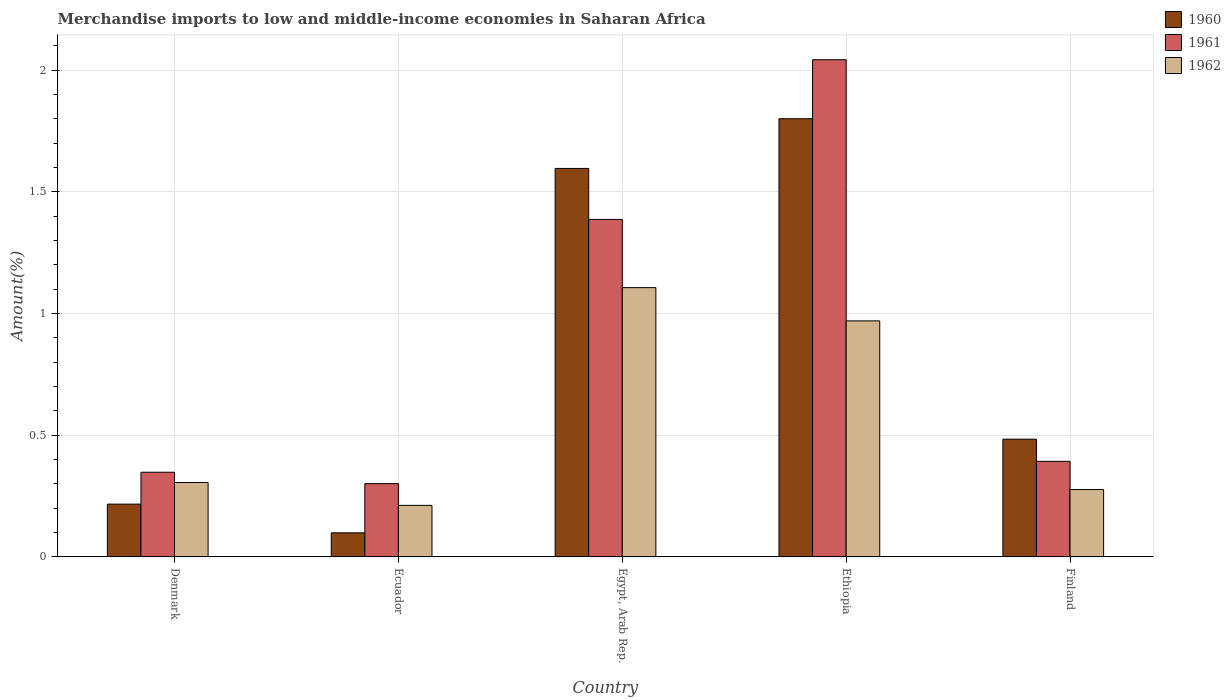How many groups of bars are there?
Give a very brief answer. 5. Are the number of bars per tick equal to the number of legend labels?
Make the answer very short. Yes. Are the number of bars on each tick of the X-axis equal?
Ensure brevity in your answer.  Yes. What is the label of the 4th group of bars from the left?
Keep it short and to the point. Ethiopia. In how many cases, is the number of bars for a given country not equal to the number of legend labels?
Offer a terse response. 0. What is the percentage of amount earned from merchandise imports in 1960 in Ecuador?
Make the answer very short. 0.1. Across all countries, what is the maximum percentage of amount earned from merchandise imports in 1960?
Give a very brief answer. 1.8. Across all countries, what is the minimum percentage of amount earned from merchandise imports in 1961?
Ensure brevity in your answer.  0.3. In which country was the percentage of amount earned from merchandise imports in 1962 maximum?
Make the answer very short. Egypt, Arab Rep. In which country was the percentage of amount earned from merchandise imports in 1960 minimum?
Make the answer very short. Ecuador. What is the total percentage of amount earned from merchandise imports in 1962 in the graph?
Provide a short and direct response. 2.87. What is the difference between the percentage of amount earned from merchandise imports in 1960 in Denmark and that in Egypt, Arab Rep.?
Make the answer very short. -1.38. What is the difference between the percentage of amount earned from merchandise imports in 1962 in Ecuador and the percentage of amount earned from merchandise imports in 1961 in Finland?
Keep it short and to the point. -0.18. What is the average percentage of amount earned from merchandise imports in 1960 per country?
Ensure brevity in your answer.  0.84. What is the difference between the percentage of amount earned from merchandise imports of/in 1960 and percentage of amount earned from merchandise imports of/in 1961 in Egypt, Arab Rep.?
Give a very brief answer. 0.21. What is the ratio of the percentage of amount earned from merchandise imports in 1960 in Ethiopia to that in Finland?
Provide a succinct answer. 3.72. Is the percentage of amount earned from merchandise imports in 1961 in Denmark less than that in Ethiopia?
Your response must be concise. Yes. Is the difference between the percentage of amount earned from merchandise imports in 1960 in Ethiopia and Finland greater than the difference between the percentage of amount earned from merchandise imports in 1961 in Ethiopia and Finland?
Your response must be concise. No. What is the difference between the highest and the second highest percentage of amount earned from merchandise imports in 1961?
Your response must be concise. -0.99. What is the difference between the highest and the lowest percentage of amount earned from merchandise imports in 1960?
Ensure brevity in your answer.  1.7. What does the 1st bar from the left in Ethiopia represents?
Provide a short and direct response. 1960. How many bars are there?
Keep it short and to the point. 15. What is the difference between two consecutive major ticks on the Y-axis?
Your response must be concise. 0.5. Are the values on the major ticks of Y-axis written in scientific E-notation?
Ensure brevity in your answer.  No. Does the graph contain grids?
Make the answer very short. Yes. Where does the legend appear in the graph?
Offer a terse response. Top right. How many legend labels are there?
Ensure brevity in your answer.  3. How are the legend labels stacked?
Your answer should be very brief. Vertical. What is the title of the graph?
Your answer should be very brief. Merchandise imports to low and middle-income economies in Saharan Africa. Does "1970" appear as one of the legend labels in the graph?
Provide a succinct answer. No. What is the label or title of the X-axis?
Your answer should be very brief. Country. What is the label or title of the Y-axis?
Provide a succinct answer. Amount(%). What is the Amount(%) in 1960 in Denmark?
Provide a succinct answer. 0.22. What is the Amount(%) of 1961 in Denmark?
Provide a short and direct response. 0.35. What is the Amount(%) of 1962 in Denmark?
Your answer should be very brief. 0.31. What is the Amount(%) in 1960 in Ecuador?
Offer a very short reply. 0.1. What is the Amount(%) in 1961 in Ecuador?
Keep it short and to the point. 0.3. What is the Amount(%) in 1962 in Ecuador?
Give a very brief answer. 0.21. What is the Amount(%) of 1960 in Egypt, Arab Rep.?
Offer a very short reply. 1.6. What is the Amount(%) of 1961 in Egypt, Arab Rep.?
Your answer should be compact. 1.39. What is the Amount(%) of 1962 in Egypt, Arab Rep.?
Offer a terse response. 1.11. What is the Amount(%) in 1960 in Ethiopia?
Your answer should be compact. 1.8. What is the Amount(%) in 1961 in Ethiopia?
Provide a succinct answer. 2.04. What is the Amount(%) in 1962 in Ethiopia?
Provide a short and direct response. 0.97. What is the Amount(%) in 1960 in Finland?
Keep it short and to the point. 0.48. What is the Amount(%) of 1961 in Finland?
Make the answer very short. 0.39. What is the Amount(%) in 1962 in Finland?
Offer a terse response. 0.28. Across all countries, what is the maximum Amount(%) in 1960?
Provide a short and direct response. 1.8. Across all countries, what is the maximum Amount(%) in 1961?
Offer a very short reply. 2.04. Across all countries, what is the maximum Amount(%) in 1962?
Ensure brevity in your answer.  1.11. Across all countries, what is the minimum Amount(%) of 1960?
Your answer should be compact. 0.1. Across all countries, what is the minimum Amount(%) in 1961?
Give a very brief answer. 0.3. Across all countries, what is the minimum Amount(%) in 1962?
Ensure brevity in your answer.  0.21. What is the total Amount(%) in 1960 in the graph?
Your answer should be compact. 4.2. What is the total Amount(%) of 1961 in the graph?
Make the answer very short. 4.47. What is the total Amount(%) of 1962 in the graph?
Your response must be concise. 2.87. What is the difference between the Amount(%) of 1960 in Denmark and that in Ecuador?
Give a very brief answer. 0.12. What is the difference between the Amount(%) of 1961 in Denmark and that in Ecuador?
Provide a succinct answer. 0.05. What is the difference between the Amount(%) in 1962 in Denmark and that in Ecuador?
Provide a short and direct response. 0.09. What is the difference between the Amount(%) in 1960 in Denmark and that in Egypt, Arab Rep.?
Provide a succinct answer. -1.38. What is the difference between the Amount(%) of 1961 in Denmark and that in Egypt, Arab Rep.?
Give a very brief answer. -1.04. What is the difference between the Amount(%) of 1962 in Denmark and that in Egypt, Arab Rep.?
Make the answer very short. -0.8. What is the difference between the Amount(%) in 1960 in Denmark and that in Ethiopia?
Your response must be concise. -1.58. What is the difference between the Amount(%) of 1961 in Denmark and that in Ethiopia?
Your answer should be compact. -1.7. What is the difference between the Amount(%) of 1962 in Denmark and that in Ethiopia?
Your response must be concise. -0.66. What is the difference between the Amount(%) in 1960 in Denmark and that in Finland?
Make the answer very short. -0.27. What is the difference between the Amount(%) in 1961 in Denmark and that in Finland?
Ensure brevity in your answer.  -0.04. What is the difference between the Amount(%) of 1962 in Denmark and that in Finland?
Provide a succinct answer. 0.03. What is the difference between the Amount(%) in 1960 in Ecuador and that in Egypt, Arab Rep.?
Keep it short and to the point. -1.5. What is the difference between the Amount(%) of 1961 in Ecuador and that in Egypt, Arab Rep.?
Your answer should be compact. -1.09. What is the difference between the Amount(%) in 1962 in Ecuador and that in Egypt, Arab Rep.?
Keep it short and to the point. -0.89. What is the difference between the Amount(%) of 1960 in Ecuador and that in Ethiopia?
Provide a short and direct response. -1.7. What is the difference between the Amount(%) in 1961 in Ecuador and that in Ethiopia?
Offer a terse response. -1.74. What is the difference between the Amount(%) in 1962 in Ecuador and that in Ethiopia?
Provide a succinct answer. -0.76. What is the difference between the Amount(%) of 1960 in Ecuador and that in Finland?
Offer a terse response. -0.38. What is the difference between the Amount(%) in 1961 in Ecuador and that in Finland?
Provide a succinct answer. -0.09. What is the difference between the Amount(%) of 1962 in Ecuador and that in Finland?
Provide a succinct answer. -0.07. What is the difference between the Amount(%) of 1960 in Egypt, Arab Rep. and that in Ethiopia?
Keep it short and to the point. -0.2. What is the difference between the Amount(%) in 1961 in Egypt, Arab Rep. and that in Ethiopia?
Your answer should be very brief. -0.66. What is the difference between the Amount(%) of 1962 in Egypt, Arab Rep. and that in Ethiopia?
Give a very brief answer. 0.14. What is the difference between the Amount(%) in 1960 in Egypt, Arab Rep. and that in Finland?
Your answer should be compact. 1.11. What is the difference between the Amount(%) in 1961 in Egypt, Arab Rep. and that in Finland?
Make the answer very short. 0.99. What is the difference between the Amount(%) in 1962 in Egypt, Arab Rep. and that in Finland?
Ensure brevity in your answer.  0.83. What is the difference between the Amount(%) in 1960 in Ethiopia and that in Finland?
Offer a terse response. 1.32. What is the difference between the Amount(%) of 1961 in Ethiopia and that in Finland?
Provide a short and direct response. 1.65. What is the difference between the Amount(%) in 1962 in Ethiopia and that in Finland?
Make the answer very short. 0.69. What is the difference between the Amount(%) in 1960 in Denmark and the Amount(%) in 1961 in Ecuador?
Make the answer very short. -0.08. What is the difference between the Amount(%) in 1960 in Denmark and the Amount(%) in 1962 in Ecuador?
Offer a terse response. 0.01. What is the difference between the Amount(%) in 1961 in Denmark and the Amount(%) in 1962 in Ecuador?
Provide a succinct answer. 0.14. What is the difference between the Amount(%) of 1960 in Denmark and the Amount(%) of 1961 in Egypt, Arab Rep.?
Give a very brief answer. -1.17. What is the difference between the Amount(%) of 1960 in Denmark and the Amount(%) of 1962 in Egypt, Arab Rep.?
Offer a terse response. -0.89. What is the difference between the Amount(%) in 1961 in Denmark and the Amount(%) in 1962 in Egypt, Arab Rep.?
Provide a succinct answer. -0.76. What is the difference between the Amount(%) of 1960 in Denmark and the Amount(%) of 1961 in Ethiopia?
Offer a terse response. -1.83. What is the difference between the Amount(%) in 1960 in Denmark and the Amount(%) in 1962 in Ethiopia?
Make the answer very short. -0.75. What is the difference between the Amount(%) in 1961 in Denmark and the Amount(%) in 1962 in Ethiopia?
Your answer should be very brief. -0.62. What is the difference between the Amount(%) of 1960 in Denmark and the Amount(%) of 1961 in Finland?
Your answer should be very brief. -0.18. What is the difference between the Amount(%) of 1960 in Denmark and the Amount(%) of 1962 in Finland?
Your response must be concise. -0.06. What is the difference between the Amount(%) in 1961 in Denmark and the Amount(%) in 1962 in Finland?
Your answer should be compact. 0.07. What is the difference between the Amount(%) in 1960 in Ecuador and the Amount(%) in 1961 in Egypt, Arab Rep.?
Offer a very short reply. -1.29. What is the difference between the Amount(%) in 1960 in Ecuador and the Amount(%) in 1962 in Egypt, Arab Rep.?
Offer a terse response. -1.01. What is the difference between the Amount(%) of 1961 in Ecuador and the Amount(%) of 1962 in Egypt, Arab Rep.?
Offer a very short reply. -0.81. What is the difference between the Amount(%) in 1960 in Ecuador and the Amount(%) in 1961 in Ethiopia?
Provide a short and direct response. -1.94. What is the difference between the Amount(%) in 1960 in Ecuador and the Amount(%) in 1962 in Ethiopia?
Offer a terse response. -0.87. What is the difference between the Amount(%) of 1961 in Ecuador and the Amount(%) of 1962 in Ethiopia?
Offer a terse response. -0.67. What is the difference between the Amount(%) of 1960 in Ecuador and the Amount(%) of 1961 in Finland?
Your answer should be compact. -0.29. What is the difference between the Amount(%) of 1960 in Ecuador and the Amount(%) of 1962 in Finland?
Your answer should be very brief. -0.18. What is the difference between the Amount(%) in 1961 in Ecuador and the Amount(%) in 1962 in Finland?
Offer a very short reply. 0.02. What is the difference between the Amount(%) of 1960 in Egypt, Arab Rep. and the Amount(%) of 1961 in Ethiopia?
Your answer should be very brief. -0.45. What is the difference between the Amount(%) in 1960 in Egypt, Arab Rep. and the Amount(%) in 1962 in Ethiopia?
Ensure brevity in your answer.  0.63. What is the difference between the Amount(%) in 1961 in Egypt, Arab Rep. and the Amount(%) in 1962 in Ethiopia?
Your answer should be compact. 0.42. What is the difference between the Amount(%) in 1960 in Egypt, Arab Rep. and the Amount(%) in 1961 in Finland?
Provide a succinct answer. 1.2. What is the difference between the Amount(%) of 1960 in Egypt, Arab Rep. and the Amount(%) of 1962 in Finland?
Ensure brevity in your answer.  1.32. What is the difference between the Amount(%) in 1961 in Egypt, Arab Rep. and the Amount(%) in 1962 in Finland?
Offer a very short reply. 1.11. What is the difference between the Amount(%) in 1960 in Ethiopia and the Amount(%) in 1961 in Finland?
Provide a short and direct response. 1.41. What is the difference between the Amount(%) in 1960 in Ethiopia and the Amount(%) in 1962 in Finland?
Offer a very short reply. 1.52. What is the difference between the Amount(%) of 1961 in Ethiopia and the Amount(%) of 1962 in Finland?
Offer a terse response. 1.77. What is the average Amount(%) of 1960 per country?
Ensure brevity in your answer.  0.84. What is the average Amount(%) in 1961 per country?
Ensure brevity in your answer.  0.89. What is the average Amount(%) of 1962 per country?
Offer a very short reply. 0.57. What is the difference between the Amount(%) of 1960 and Amount(%) of 1961 in Denmark?
Your answer should be compact. -0.13. What is the difference between the Amount(%) of 1960 and Amount(%) of 1962 in Denmark?
Your response must be concise. -0.09. What is the difference between the Amount(%) of 1961 and Amount(%) of 1962 in Denmark?
Make the answer very short. 0.04. What is the difference between the Amount(%) of 1960 and Amount(%) of 1961 in Ecuador?
Make the answer very short. -0.2. What is the difference between the Amount(%) of 1960 and Amount(%) of 1962 in Ecuador?
Your response must be concise. -0.11. What is the difference between the Amount(%) in 1961 and Amount(%) in 1962 in Ecuador?
Provide a short and direct response. 0.09. What is the difference between the Amount(%) in 1960 and Amount(%) in 1961 in Egypt, Arab Rep.?
Offer a terse response. 0.21. What is the difference between the Amount(%) in 1960 and Amount(%) in 1962 in Egypt, Arab Rep.?
Offer a terse response. 0.49. What is the difference between the Amount(%) of 1961 and Amount(%) of 1962 in Egypt, Arab Rep.?
Make the answer very short. 0.28. What is the difference between the Amount(%) in 1960 and Amount(%) in 1961 in Ethiopia?
Your answer should be very brief. -0.24. What is the difference between the Amount(%) in 1960 and Amount(%) in 1962 in Ethiopia?
Provide a short and direct response. 0.83. What is the difference between the Amount(%) of 1961 and Amount(%) of 1962 in Ethiopia?
Make the answer very short. 1.07. What is the difference between the Amount(%) of 1960 and Amount(%) of 1961 in Finland?
Offer a terse response. 0.09. What is the difference between the Amount(%) of 1960 and Amount(%) of 1962 in Finland?
Offer a very short reply. 0.21. What is the difference between the Amount(%) of 1961 and Amount(%) of 1962 in Finland?
Give a very brief answer. 0.12. What is the ratio of the Amount(%) of 1960 in Denmark to that in Ecuador?
Your response must be concise. 2.19. What is the ratio of the Amount(%) of 1961 in Denmark to that in Ecuador?
Your answer should be compact. 1.16. What is the ratio of the Amount(%) of 1962 in Denmark to that in Ecuador?
Your answer should be compact. 1.44. What is the ratio of the Amount(%) in 1960 in Denmark to that in Egypt, Arab Rep.?
Offer a terse response. 0.14. What is the ratio of the Amount(%) in 1961 in Denmark to that in Egypt, Arab Rep.?
Provide a succinct answer. 0.25. What is the ratio of the Amount(%) of 1962 in Denmark to that in Egypt, Arab Rep.?
Ensure brevity in your answer.  0.28. What is the ratio of the Amount(%) in 1960 in Denmark to that in Ethiopia?
Ensure brevity in your answer.  0.12. What is the ratio of the Amount(%) of 1961 in Denmark to that in Ethiopia?
Provide a succinct answer. 0.17. What is the ratio of the Amount(%) of 1962 in Denmark to that in Ethiopia?
Your answer should be very brief. 0.32. What is the ratio of the Amount(%) in 1960 in Denmark to that in Finland?
Make the answer very short. 0.45. What is the ratio of the Amount(%) of 1961 in Denmark to that in Finland?
Make the answer very short. 0.89. What is the ratio of the Amount(%) in 1962 in Denmark to that in Finland?
Offer a very short reply. 1.1. What is the ratio of the Amount(%) of 1960 in Ecuador to that in Egypt, Arab Rep.?
Make the answer very short. 0.06. What is the ratio of the Amount(%) in 1961 in Ecuador to that in Egypt, Arab Rep.?
Give a very brief answer. 0.22. What is the ratio of the Amount(%) in 1962 in Ecuador to that in Egypt, Arab Rep.?
Ensure brevity in your answer.  0.19. What is the ratio of the Amount(%) of 1960 in Ecuador to that in Ethiopia?
Provide a short and direct response. 0.06. What is the ratio of the Amount(%) of 1961 in Ecuador to that in Ethiopia?
Your response must be concise. 0.15. What is the ratio of the Amount(%) in 1962 in Ecuador to that in Ethiopia?
Keep it short and to the point. 0.22. What is the ratio of the Amount(%) in 1960 in Ecuador to that in Finland?
Your response must be concise. 0.2. What is the ratio of the Amount(%) of 1961 in Ecuador to that in Finland?
Offer a terse response. 0.77. What is the ratio of the Amount(%) in 1962 in Ecuador to that in Finland?
Provide a succinct answer. 0.77. What is the ratio of the Amount(%) of 1960 in Egypt, Arab Rep. to that in Ethiopia?
Make the answer very short. 0.89. What is the ratio of the Amount(%) in 1961 in Egypt, Arab Rep. to that in Ethiopia?
Provide a short and direct response. 0.68. What is the ratio of the Amount(%) of 1962 in Egypt, Arab Rep. to that in Ethiopia?
Your answer should be compact. 1.14. What is the ratio of the Amount(%) in 1960 in Egypt, Arab Rep. to that in Finland?
Keep it short and to the point. 3.3. What is the ratio of the Amount(%) of 1961 in Egypt, Arab Rep. to that in Finland?
Offer a terse response. 3.53. What is the ratio of the Amount(%) of 1962 in Egypt, Arab Rep. to that in Finland?
Give a very brief answer. 4. What is the ratio of the Amount(%) in 1960 in Ethiopia to that in Finland?
Keep it short and to the point. 3.72. What is the ratio of the Amount(%) of 1961 in Ethiopia to that in Finland?
Offer a very short reply. 5.2. What is the ratio of the Amount(%) of 1962 in Ethiopia to that in Finland?
Offer a very short reply. 3.5. What is the difference between the highest and the second highest Amount(%) in 1960?
Make the answer very short. 0.2. What is the difference between the highest and the second highest Amount(%) of 1961?
Your response must be concise. 0.66. What is the difference between the highest and the second highest Amount(%) in 1962?
Your response must be concise. 0.14. What is the difference between the highest and the lowest Amount(%) of 1960?
Keep it short and to the point. 1.7. What is the difference between the highest and the lowest Amount(%) in 1961?
Your answer should be very brief. 1.74. What is the difference between the highest and the lowest Amount(%) of 1962?
Your answer should be compact. 0.89. 